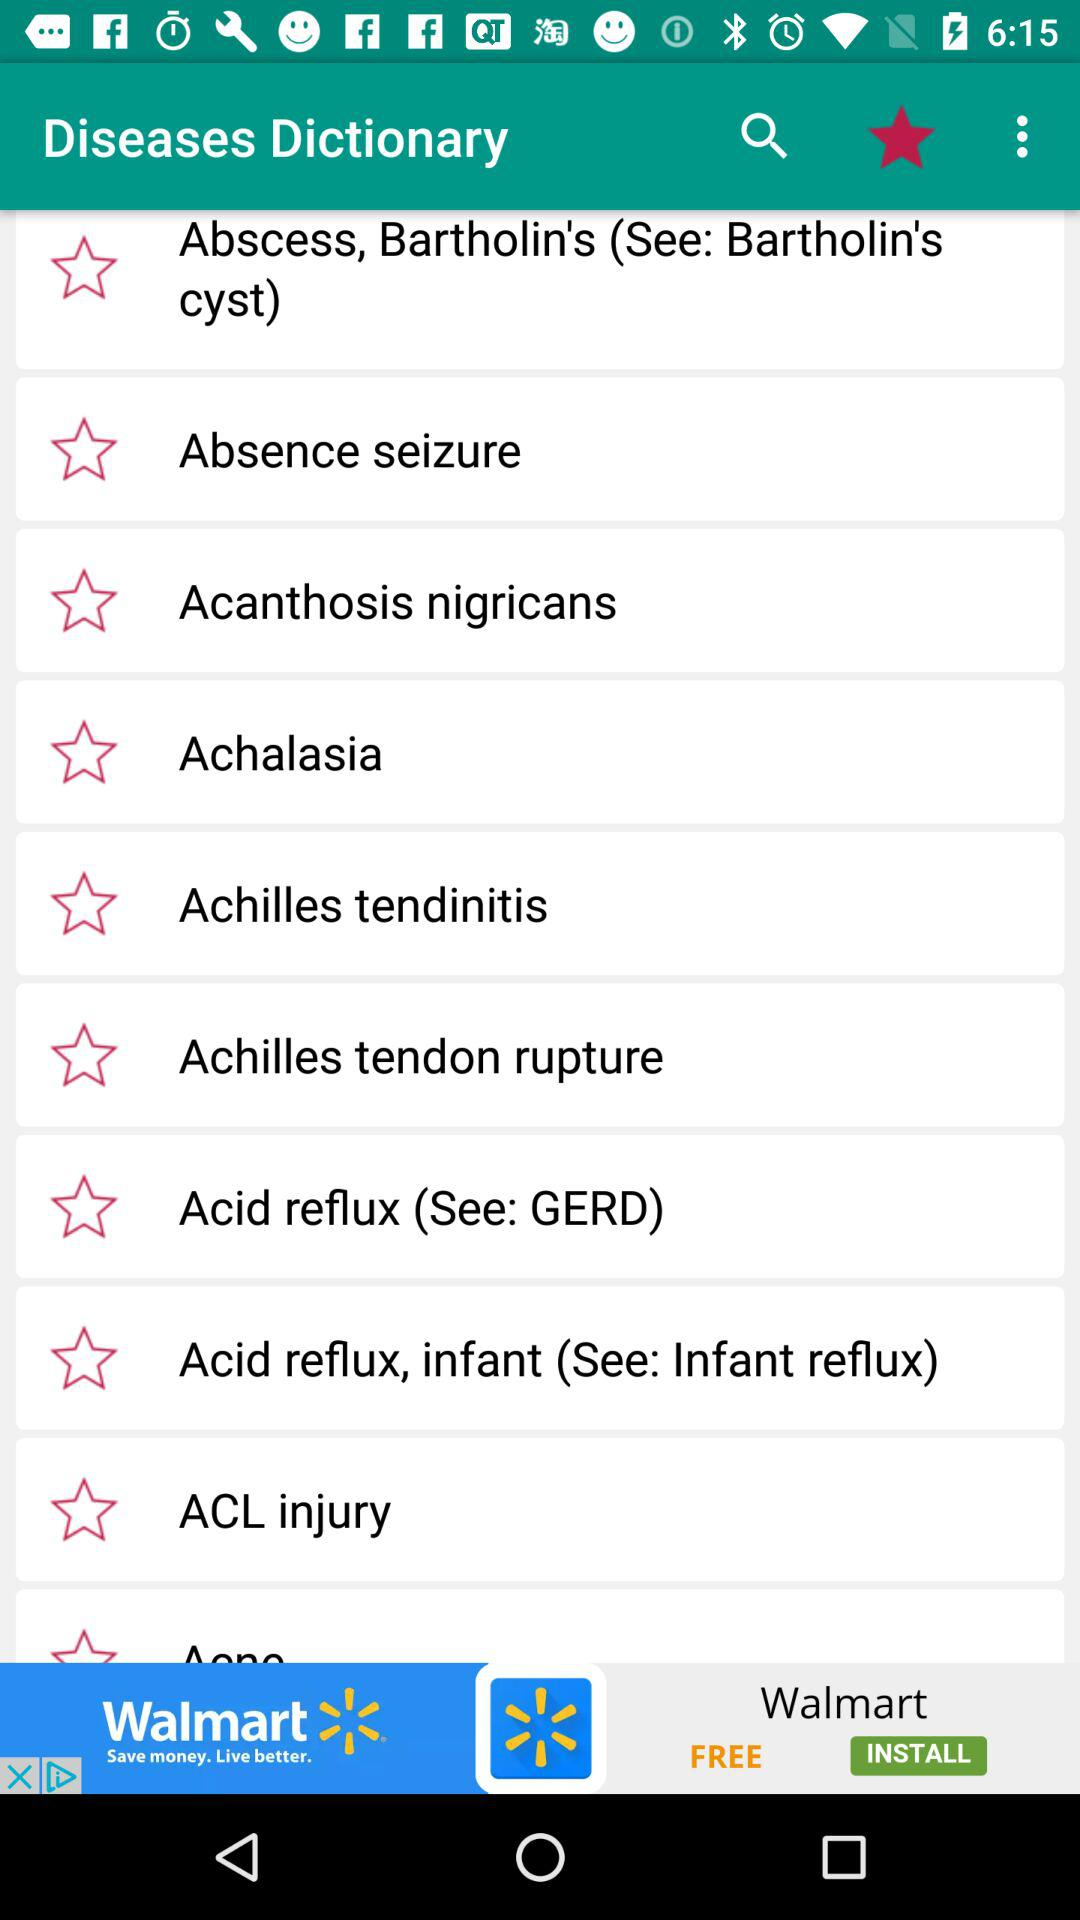What is the alternative name for acid reflux, infant? The alternative name is infant reflux. 